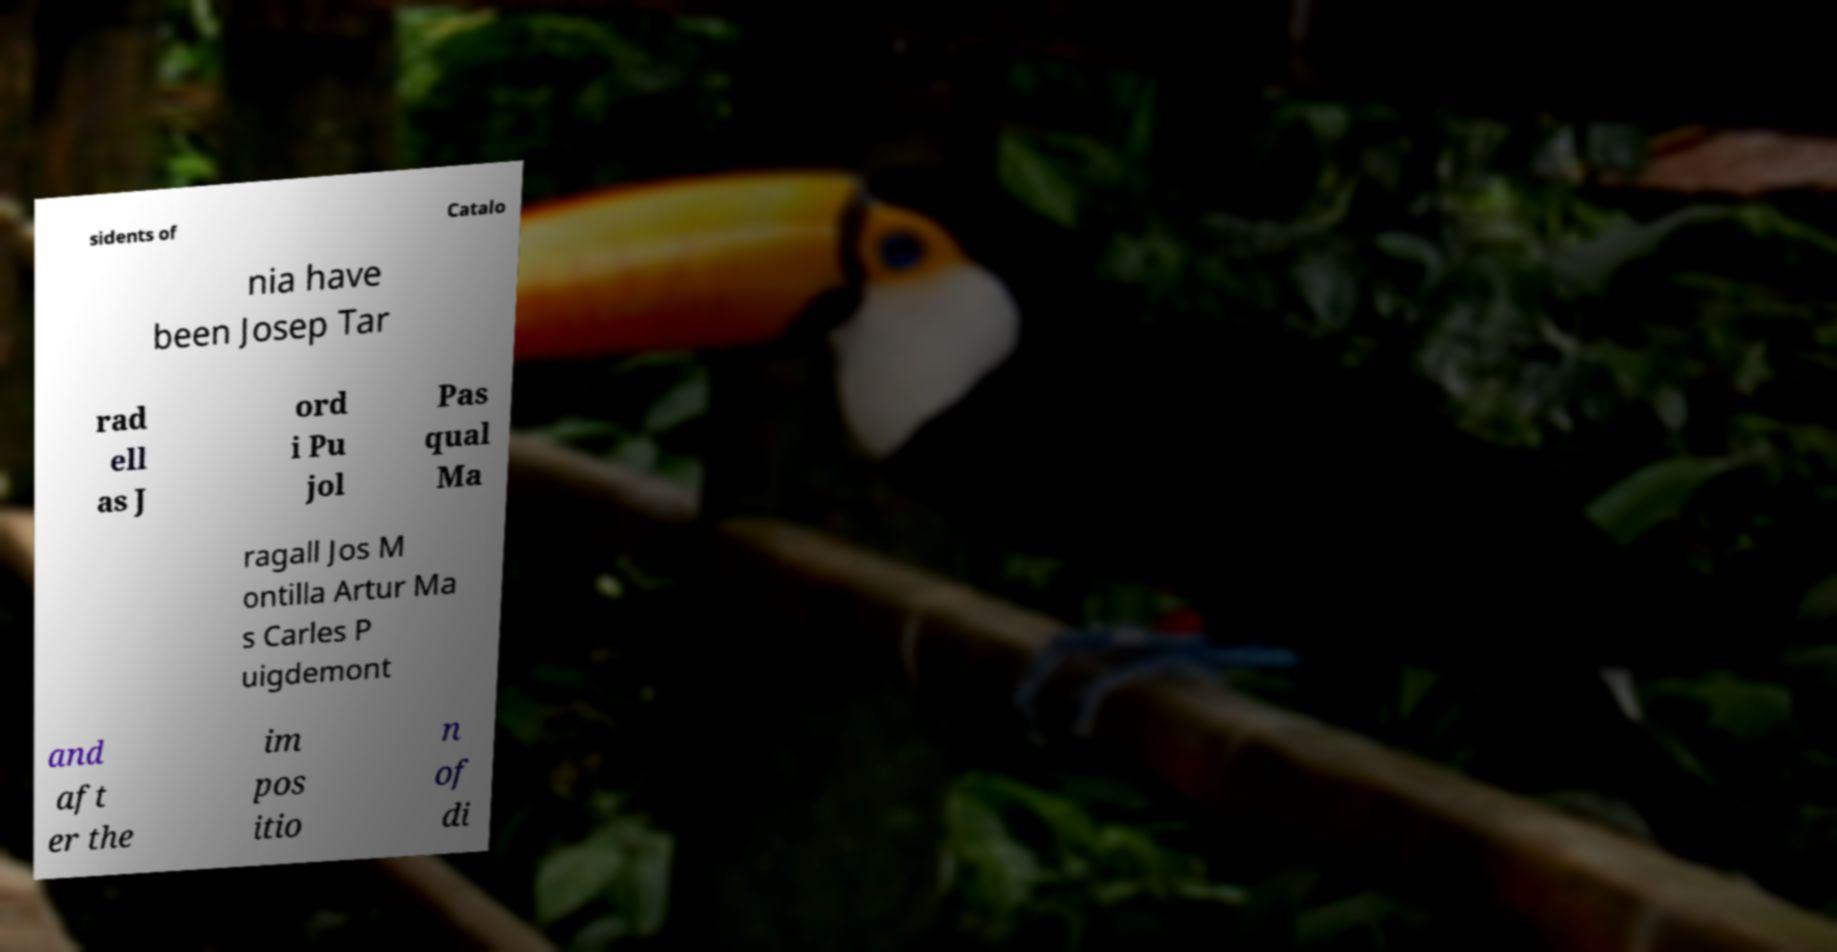What messages or text are displayed in this image? I need them in a readable, typed format. sidents of Catalo nia have been Josep Tar rad ell as J ord i Pu jol Pas qual Ma ragall Jos M ontilla Artur Ma s Carles P uigdemont and aft er the im pos itio n of di 